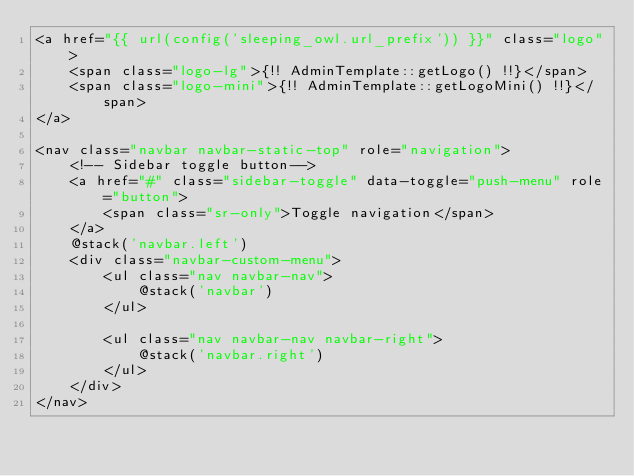<code> <loc_0><loc_0><loc_500><loc_500><_PHP_><a href="{{ url(config('sleeping_owl.url_prefix')) }}" class="logo">
	<span class="logo-lg">{!! AdminTemplate::getLogo() !!}</span>
	<span class="logo-mini">{!! AdminTemplate::getLogoMini() !!}</span>
</a>

<nav class="navbar navbar-static-top" role="navigation">
	<!-- Sidebar toggle button-->
	<a href="#" class="sidebar-toggle" data-toggle="push-menu" role="button">
		<span class="sr-only">Toggle navigation</span>
	</a>
	@stack('navbar.left')	
	<div class="navbar-custom-menu">	
		<ul class="nav navbar-nav">
			@stack('navbar')
		</ul>

		<ul class="nav navbar-nav navbar-right">
			@stack('navbar.right')
		</ul>
	</div>
</nav>
</code> 